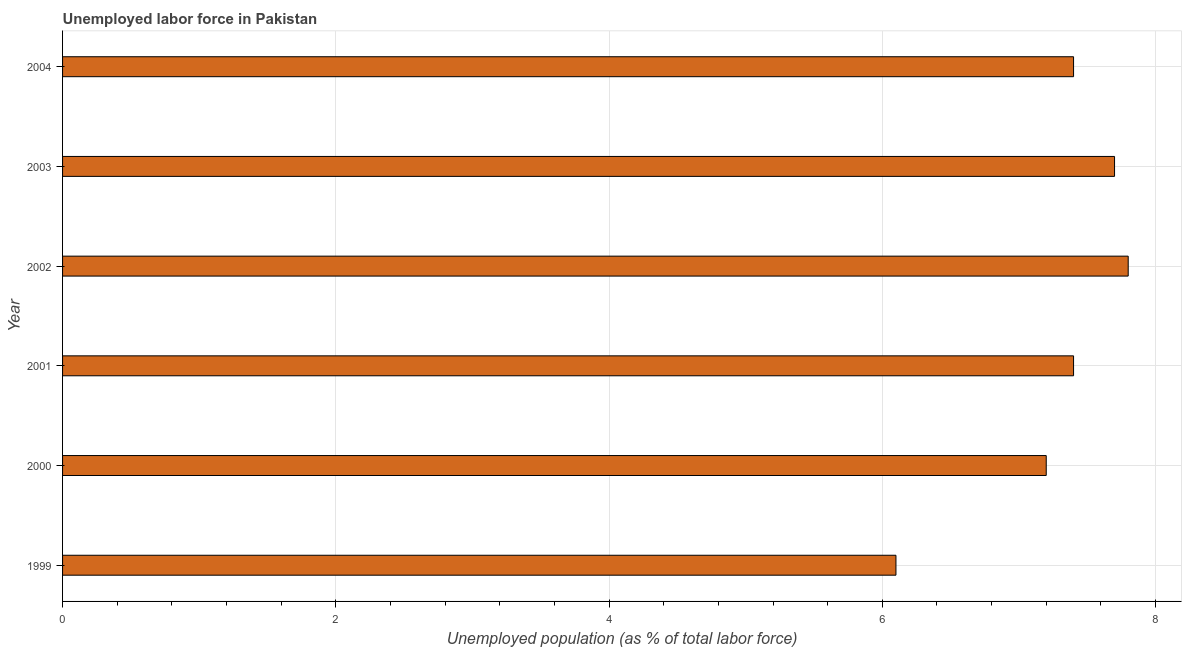What is the title of the graph?
Your answer should be very brief. Unemployed labor force in Pakistan. What is the label or title of the X-axis?
Your answer should be compact. Unemployed population (as % of total labor force). What is the total unemployed population in 1999?
Your response must be concise. 6.1. Across all years, what is the maximum total unemployed population?
Your response must be concise. 7.8. Across all years, what is the minimum total unemployed population?
Keep it short and to the point. 6.1. In which year was the total unemployed population maximum?
Offer a very short reply. 2002. What is the sum of the total unemployed population?
Offer a very short reply. 43.6. What is the difference between the total unemployed population in 1999 and 2003?
Your answer should be very brief. -1.6. What is the average total unemployed population per year?
Ensure brevity in your answer.  7.27. What is the median total unemployed population?
Give a very brief answer. 7.4. Do a majority of the years between 2002 and 2004 (inclusive) have total unemployed population greater than 1.6 %?
Provide a succinct answer. Yes. What is the ratio of the total unemployed population in 1999 to that in 2000?
Your response must be concise. 0.85. Is the total unemployed population in 2000 less than that in 2003?
Ensure brevity in your answer.  Yes. Is the difference between the total unemployed population in 1999 and 2000 greater than the difference between any two years?
Your answer should be compact. No. What is the difference between the highest and the second highest total unemployed population?
Offer a terse response. 0.1. Is the sum of the total unemployed population in 2001 and 2003 greater than the maximum total unemployed population across all years?
Provide a succinct answer. Yes. What is the difference between the highest and the lowest total unemployed population?
Offer a terse response. 1.7. In how many years, is the total unemployed population greater than the average total unemployed population taken over all years?
Your answer should be compact. 4. Are all the bars in the graph horizontal?
Your answer should be very brief. Yes. How many years are there in the graph?
Provide a short and direct response. 6. What is the difference between two consecutive major ticks on the X-axis?
Offer a terse response. 2. Are the values on the major ticks of X-axis written in scientific E-notation?
Offer a very short reply. No. What is the Unemployed population (as % of total labor force) of 1999?
Give a very brief answer. 6.1. What is the Unemployed population (as % of total labor force) of 2000?
Ensure brevity in your answer.  7.2. What is the Unemployed population (as % of total labor force) in 2001?
Provide a succinct answer. 7.4. What is the Unemployed population (as % of total labor force) of 2002?
Offer a very short reply. 7.8. What is the Unemployed population (as % of total labor force) of 2003?
Offer a very short reply. 7.7. What is the Unemployed population (as % of total labor force) in 2004?
Your answer should be very brief. 7.4. What is the difference between the Unemployed population (as % of total labor force) in 1999 and 2001?
Make the answer very short. -1.3. What is the difference between the Unemployed population (as % of total labor force) in 1999 and 2002?
Give a very brief answer. -1.7. What is the difference between the Unemployed population (as % of total labor force) in 1999 and 2003?
Your response must be concise. -1.6. What is the difference between the Unemployed population (as % of total labor force) in 2000 and 2002?
Ensure brevity in your answer.  -0.6. What is the difference between the Unemployed population (as % of total labor force) in 2001 and 2003?
Your response must be concise. -0.3. What is the difference between the Unemployed population (as % of total labor force) in 2001 and 2004?
Your response must be concise. 0. What is the difference between the Unemployed population (as % of total labor force) in 2002 and 2004?
Make the answer very short. 0.4. What is the difference between the Unemployed population (as % of total labor force) in 2003 and 2004?
Provide a short and direct response. 0.3. What is the ratio of the Unemployed population (as % of total labor force) in 1999 to that in 2000?
Offer a terse response. 0.85. What is the ratio of the Unemployed population (as % of total labor force) in 1999 to that in 2001?
Make the answer very short. 0.82. What is the ratio of the Unemployed population (as % of total labor force) in 1999 to that in 2002?
Offer a terse response. 0.78. What is the ratio of the Unemployed population (as % of total labor force) in 1999 to that in 2003?
Ensure brevity in your answer.  0.79. What is the ratio of the Unemployed population (as % of total labor force) in 1999 to that in 2004?
Give a very brief answer. 0.82. What is the ratio of the Unemployed population (as % of total labor force) in 2000 to that in 2002?
Keep it short and to the point. 0.92. What is the ratio of the Unemployed population (as % of total labor force) in 2000 to that in 2003?
Make the answer very short. 0.94. What is the ratio of the Unemployed population (as % of total labor force) in 2001 to that in 2002?
Ensure brevity in your answer.  0.95. What is the ratio of the Unemployed population (as % of total labor force) in 2002 to that in 2003?
Your response must be concise. 1.01. What is the ratio of the Unemployed population (as % of total labor force) in 2002 to that in 2004?
Your answer should be very brief. 1.05. What is the ratio of the Unemployed population (as % of total labor force) in 2003 to that in 2004?
Your answer should be compact. 1.04. 